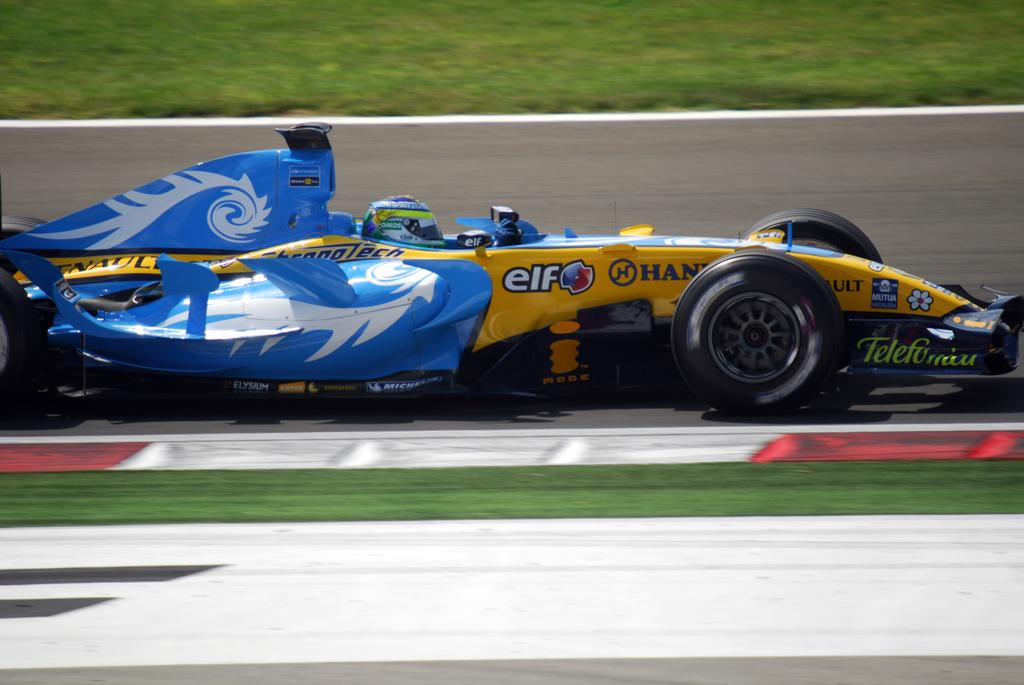What type of event is taking place in the image? The image is taken at a formula one race. What can be seen in the foreground of the image? There is grass and a road in the foreground of the image. What is happening on the road in the center of the image? A go-kart is moving on the road in the center of the image. What is visible at the top of the image? There is grass visible at the top of the image. What type of notebook is being used by the protesting ladybug in the image? There is no notebook, protest, or ladybug present in the image. 